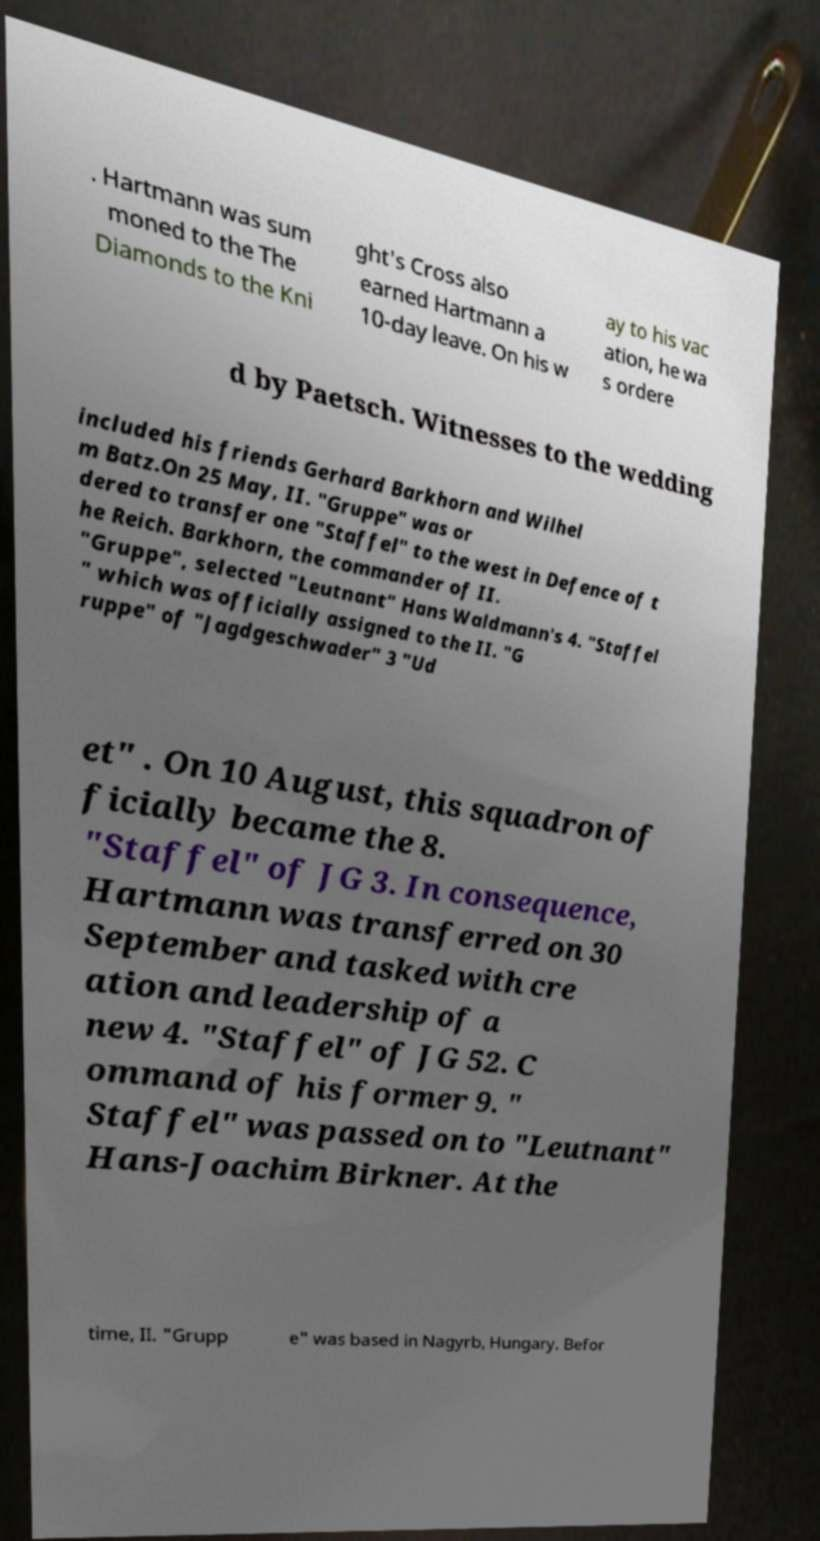Could you assist in decoding the text presented in this image and type it out clearly? . Hartmann was sum moned to the The Diamonds to the Kni ght's Cross also earned Hartmann a 10-day leave. On his w ay to his vac ation, he wa s ordere d by Paetsch. Witnesses to the wedding included his friends Gerhard Barkhorn and Wilhel m Batz.On 25 May, II. "Gruppe" was or dered to transfer one "Staffel" to the west in Defence of t he Reich. Barkhorn, the commander of II. "Gruppe", selected "Leutnant" Hans Waldmann's 4. "Staffel " which was officially assigned to the II. "G ruppe" of "Jagdgeschwader" 3 "Ud et" . On 10 August, this squadron of ficially became the 8. "Staffel" of JG 3. In consequence, Hartmann was transferred on 30 September and tasked with cre ation and leadership of a new 4. "Staffel" of JG 52. C ommand of his former 9. " Staffel" was passed on to "Leutnant" Hans-Joachim Birkner. At the time, II. "Grupp e" was based in Nagyrb, Hungary. Befor 